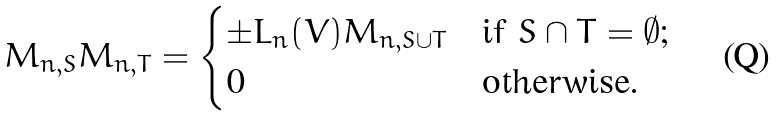<formula> <loc_0><loc_0><loc_500><loc_500>M _ { n , S } M _ { n , T } = \begin{cases} \pm L _ { n } ( V ) M _ { n , S \cup T } & \text {if $S \cap T = \emptyset$;} \\ 0 & \text {otherwise.} \end{cases}</formula> 